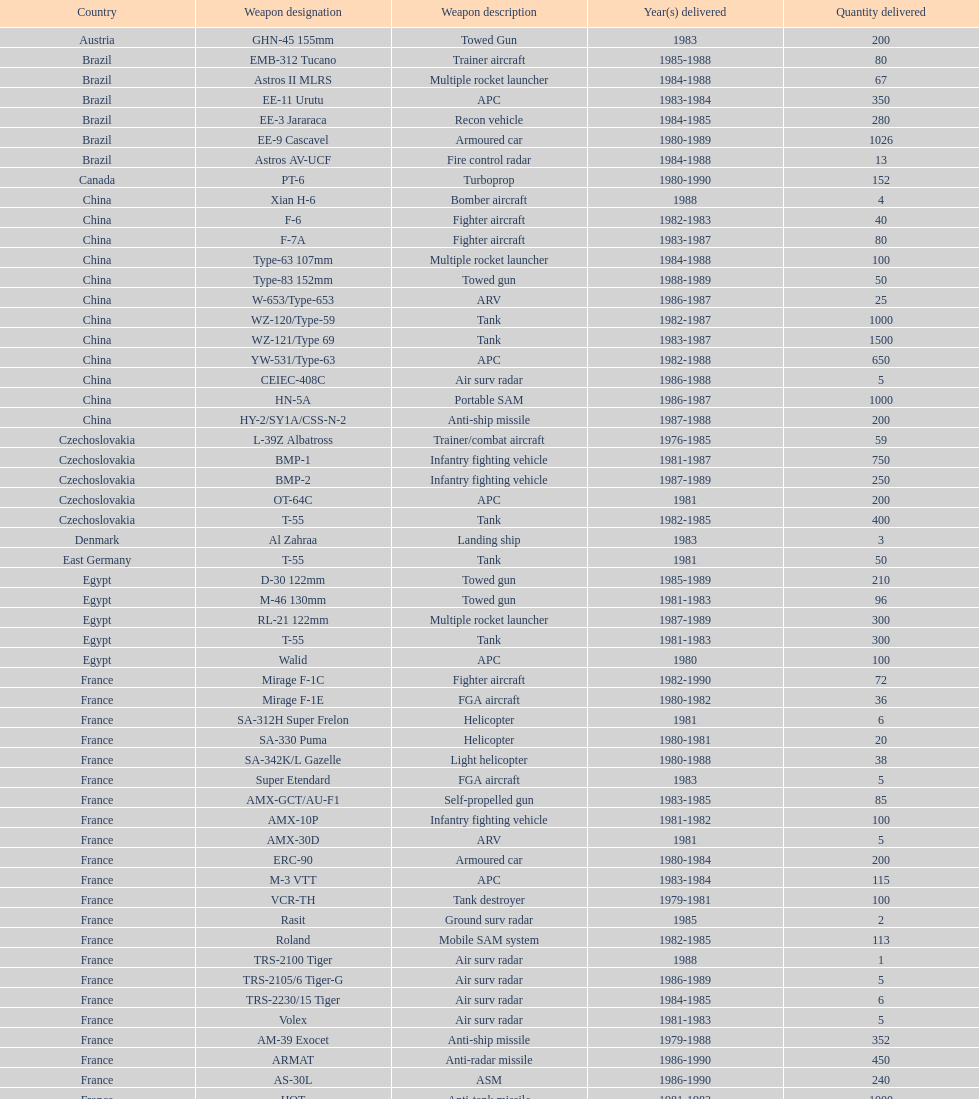How many tanks has china sold to iraq in total? 2500. Could you parse the entire table? {'header': ['Country', 'Weapon designation', 'Weapon description', 'Year(s) delivered', 'Quantity delivered'], 'rows': [['Austria', 'GHN-45 155mm', 'Towed Gun', '1983', '200'], ['Brazil', 'EMB-312 Tucano', 'Trainer aircraft', '1985-1988', '80'], ['Brazil', 'Astros II MLRS', 'Multiple rocket launcher', '1984-1988', '67'], ['Brazil', 'EE-11 Urutu', 'APC', '1983-1984', '350'], ['Brazil', 'EE-3 Jararaca', 'Recon vehicle', '1984-1985', '280'], ['Brazil', 'EE-9 Cascavel', 'Armoured car', '1980-1989', '1026'], ['Brazil', 'Astros AV-UCF', 'Fire control radar', '1984-1988', '13'], ['Canada', 'PT-6', 'Turboprop', '1980-1990', '152'], ['China', 'Xian H-6', 'Bomber aircraft', '1988', '4'], ['China', 'F-6', 'Fighter aircraft', '1982-1983', '40'], ['China', 'F-7A', 'Fighter aircraft', '1983-1987', '80'], ['China', 'Type-63 107mm', 'Multiple rocket launcher', '1984-1988', '100'], ['China', 'Type-83 152mm', 'Towed gun', '1988-1989', '50'], ['China', 'W-653/Type-653', 'ARV', '1986-1987', '25'], ['China', 'WZ-120/Type-59', 'Tank', '1982-1987', '1000'], ['China', 'WZ-121/Type 69', 'Tank', '1983-1987', '1500'], ['China', 'YW-531/Type-63', 'APC', '1982-1988', '650'], ['China', 'CEIEC-408C', 'Air surv radar', '1986-1988', '5'], ['China', 'HN-5A', 'Portable SAM', '1986-1987', '1000'], ['China', 'HY-2/SY1A/CSS-N-2', 'Anti-ship missile', '1987-1988', '200'], ['Czechoslovakia', 'L-39Z Albatross', 'Trainer/combat aircraft', '1976-1985', '59'], ['Czechoslovakia', 'BMP-1', 'Infantry fighting vehicle', '1981-1987', '750'], ['Czechoslovakia', 'BMP-2', 'Infantry fighting vehicle', '1987-1989', '250'], ['Czechoslovakia', 'OT-64C', 'APC', '1981', '200'], ['Czechoslovakia', 'T-55', 'Tank', '1982-1985', '400'], ['Denmark', 'Al Zahraa', 'Landing ship', '1983', '3'], ['East Germany', 'T-55', 'Tank', '1981', '50'], ['Egypt', 'D-30 122mm', 'Towed gun', '1985-1989', '210'], ['Egypt', 'M-46 130mm', 'Towed gun', '1981-1983', '96'], ['Egypt', 'RL-21 122mm', 'Multiple rocket launcher', '1987-1989', '300'], ['Egypt', 'T-55', 'Tank', '1981-1983', '300'], ['Egypt', 'Walid', 'APC', '1980', '100'], ['France', 'Mirage F-1C', 'Fighter aircraft', '1982-1990', '72'], ['France', 'Mirage F-1E', 'FGA aircraft', '1980-1982', '36'], ['France', 'SA-312H Super Frelon', 'Helicopter', '1981', '6'], ['France', 'SA-330 Puma', 'Helicopter', '1980-1981', '20'], ['France', 'SA-342K/L Gazelle', 'Light helicopter', '1980-1988', '38'], ['France', 'Super Etendard', 'FGA aircraft', '1983', '5'], ['France', 'AMX-GCT/AU-F1', 'Self-propelled gun', '1983-1985', '85'], ['France', 'AMX-10P', 'Infantry fighting vehicle', '1981-1982', '100'], ['France', 'AMX-30D', 'ARV', '1981', '5'], ['France', 'ERC-90', 'Armoured car', '1980-1984', '200'], ['France', 'M-3 VTT', 'APC', '1983-1984', '115'], ['France', 'VCR-TH', 'Tank destroyer', '1979-1981', '100'], ['France', 'Rasit', 'Ground surv radar', '1985', '2'], ['France', 'Roland', 'Mobile SAM system', '1982-1985', '113'], ['France', 'TRS-2100 Tiger', 'Air surv radar', '1988', '1'], ['France', 'TRS-2105/6 Tiger-G', 'Air surv radar', '1986-1989', '5'], ['France', 'TRS-2230/15 Tiger', 'Air surv radar', '1984-1985', '6'], ['France', 'Volex', 'Air surv radar', '1981-1983', '5'], ['France', 'AM-39 Exocet', 'Anti-ship missile', '1979-1988', '352'], ['France', 'ARMAT', 'Anti-radar missile', '1986-1990', '450'], ['France', 'AS-30L', 'ASM', '1986-1990', '240'], ['France', 'HOT', 'Anti-tank missile', '1981-1982', '1000'], ['France', 'R-550 Magic-1', 'SRAAM', '1981-1985', '534'], ['France', 'Roland-2', 'SAM', '1981-1990', '2260'], ['France', 'Super 530F', 'BVRAAM', '1981-1985', '300'], ['West Germany', 'BK-117', 'Helicopter', '1984-1989', '22'], ['West Germany', 'Bo-105C', 'Light Helicopter', '1979-1982', '20'], ['West Germany', 'Bo-105L', 'Light Helicopter', '1988', '6'], ['Hungary', 'PSZH-D-994', 'APC', '1981', '300'], ['Italy', 'A-109 Hirundo', 'Light Helicopter', '1982', '2'], ['Italy', 'S-61', 'Helicopter', '1982', '6'], ['Italy', 'Stromboli class', 'Support ship', '1981', '1'], ['Jordan', 'S-76 Spirit', 'Helicopter', '1985', '2'], ['Poland', 'Mi-2/Hoplite', 'Helicopter', '1984-1985', '15'], ['Poland', 'MT-LB', 'APC', '1983-1990', '750'], ['Poland', 'T-55', 'Tank', '1981-1982', '400'], ['Poland', 'T-72M1', 'Tank', '1982-1990', '500'], ['Romania', 'T-55', 'Tank', '1982-1984', '150'], ['Yugoslavia', 'M-87 Orkan 262mm', 'Multiple rocket launcher', '1988', '2'], ['South Africa', 'G-5 155mm', 'Towed gun', '1985-1988', '200'], ['Switzerland', 'PC-7 Turbo trainer', 'Trainer aircraft', '1980-1983', '52'], ['Switzerland', 'PC-9', 'Trainer aircraft', '1987-1990', '20'], ['Switzerland', 'Roland', 'APC/IFV', '1981', '100'], ['United Kingdom', 'Chieftain/ARV', 'ARV', '1982', '29'], ['United Kingdom', 'Cymbeline', 'Arty locating radar', '1986-1988', '10'], ['United States', 'MD-500MD Defender', 'Light Helicopter', '1983', '30'], ['United States', 'Hughes-300/TH-55', 'Light Helicopter', '1983', '30'], ['United States', 'MD-530F', 'Light Helicopter', '1986', '26'], ['United States', 'Bell 214ST', 'Helicopter', '1988', '31'], ['Soviet Union', 'Il-76M/Candid-B', 'Strategic airlifter', '1978-1984', '33'], ['Soviet Union', 'Mi-24D/Mi-25/Hind-D', 'Attack helicopter', '1978-1984', '12'], ['Soviet Union', 'Mi-8/Mi-17/Hip-H', 'Transport helicopter', '1986-1987', '37'], ['Soviet Union', 'Mi-8TV/Hip-F', 'Transport helicopter', '1984', '30'], ['Soviet Union', 'Mig-21bis/Fishbed-N', 'Fighter aircraft', '1983-1984', '61'], ['Soviet Union', 'Mig-23BN/Flogger-H', 'FGA aircraft', '1984-1985', '50'], ['Soviet Union', 'Mig-25P/Foxbat-A', 'Interceptor aircraft', '1980-1985', '55'], ['Soviet Union', 'Mig-25RB/Foxbat-B', 'Recon aircraft', '1982', '8'], ['Soviet Union', 'Mig-29/Fulcrum-A', 'Fighter aircraft', '1986-1989', '41'], ['Soviet Union', 'Su-22/Fitter-H/J/K', 'FGA aircraft', '1986-1987', '61'], ['Soviet Union', 'Su-25/Frogfoot-A', 'Ground attack aircraft', '1986-1987', '84'], ['Soviet Union', '2A36 152mm', 'Towed gun', '1986-1988', '180'], ['Soviet Union', '2S1 122mm', 'Self-Propelled Howitzer', '1980-1989', '150'], ['Soviet Union', '2S3 152mm', 'Self-propelled gun', '1980-1989', '150'], ['Soviet Union', '2S4 240mm', 'Self-propelled mortar', '1983', '10'], ['Soviet Union', '9P117/SS-1 Scud TEL', 'SSM launcher', '1983-1984', '10'], ['Soviet Union', 'BM-21 Grad 122mm', 'Multiple rocket launcher', '1983-1988', '560'], ['Soviet Union', 'D-30 122mm', 'Towed gun', '1982-1988', '576'], ['Soviet Union', 'M-240 240mm', 'Mortar', '1981', '25'], ['Soviet Union', 'M-46 130mm', 'Towed Gun', '1982-1987', '576'], ['Soviet Union', '9K35 Strela-10/SA-13', 'AAV(M)', '1985', '30'], ['Soviet Union', 'BMD-1', 'IFV', '1981', '10'], ['Soviet Union', 'PT-76', 'Light tank', '1984', '200'], ['Soviet Union', 'SA-9/9P31', 'AAV(M)', '1982-1985', '160'], ['Soviet Union', 'Long Track', 'Air surv radar', '1980-1984', '10'], ['Soviet Union', 'SA-8b/9K33M Osa AK', 'Mobile SAM system', '1982-1985', '50'], ['Soviet Union', 'Thin Skin', 'Air surv radar', '1980-1984', '5'], ['Soviet Union', '9M111/AT-4 Spigot', 'Anti-tank missile', '1986-1989', '3000'], ['Soviet Union', '9M37/SA-13 Gopher', 'SAM', '1985-1986', '960'], ['Soviet Union', 'KSR-5/AS-6 Kingfish', 'Anti-ship missile', '1984', '36'], ['Soviet Union', 'Kh-28/AS-9 Kyle', 'Anti-radar missile', '1983-1988', '250'], ['Soviet Union', 'R-13S/AA2S Atoll', 'SRAAM', '1984-1987', '1080'], ['Soviet Union', 'R-17/SS-1c Scud-B', 'SSM', '1982-1988', '840'], ['Soviet Union', 'R-27/AA-10 Alamo', 'BVRAAM', '1986-1989', '246'], ['Soviet Union', 'R-40R/AA-6 Acrid', 'BVRAAM', '1980-1985', '660'], ['Soviet Union', 'R-60/AA-8 Aphid', 'SRAAM', '1986-1989', '582'], ['Soviet Union', 'SA-8b Gecko/9M33M', 'SAM', '1982-1985', '1290'], ['Soviet Union', 'SA-9 Gaskin/9M31', 'SAM', '1982-1985', '1920'], ['Soviet Union', 'Strela-3/SA-14 Gremlin', 'Portable SAM', '1987-1988', '500']]} 